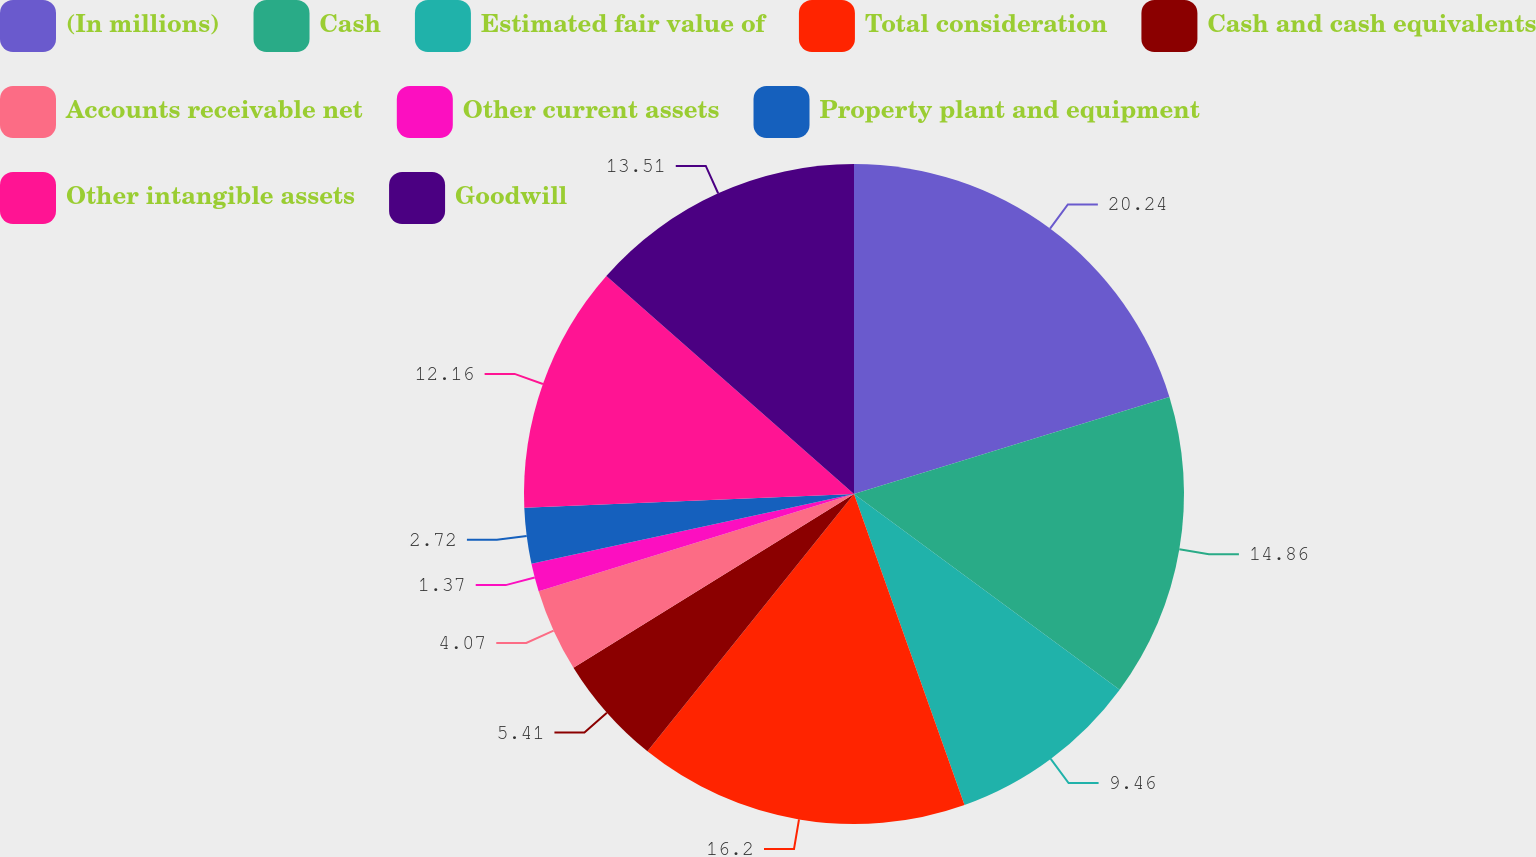Convert chart to OTSL. <chart><loc_0><loc_0><loc_500><loc_500><pie_chart><fcel>(In millions)<fcel>Cash<fcel>Estimated fair value of<fcel>Total consideration<fcel>Cash and cash equivalents<fcel>Accounts receivable net<fcel>Other current assets<fcel>Property plant and equipment<fcel>Other intangible assets<fcel>Goodwill<nl><fcel>20.25%<fcel>14.86%<fcel>9.46%<fcel>16.2%<fcel>5.41%<fcel>4.07%<fcel>1.37%<fcel>2.72%<fcel>12.16%<fcel>13.51%<nl></chart> 